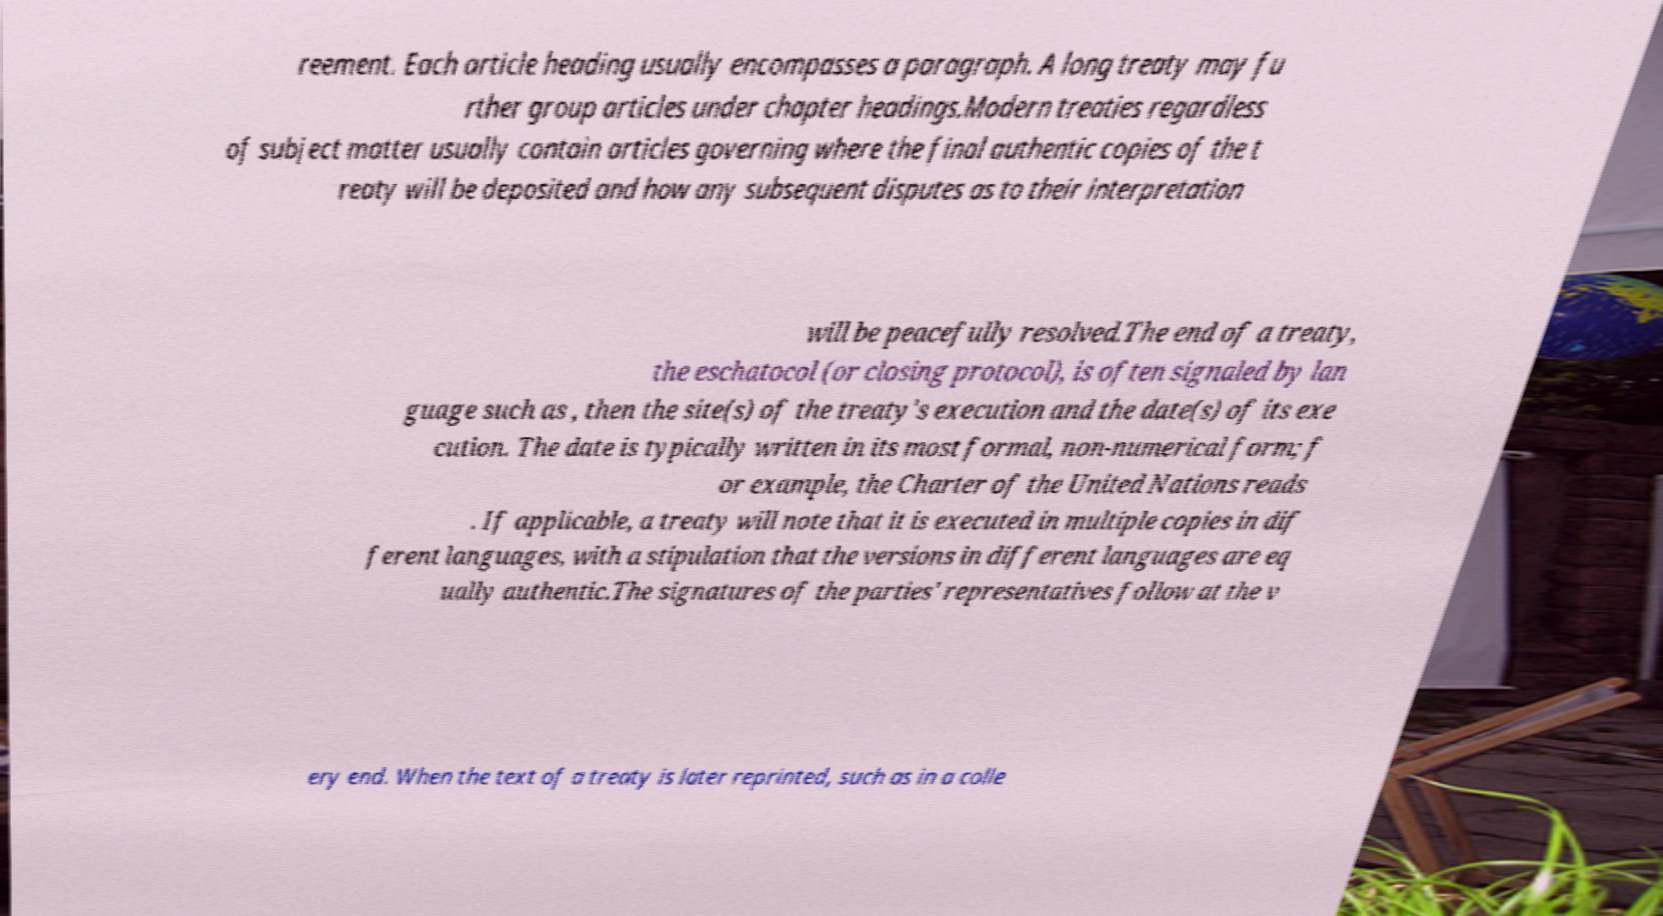Could you extract and type out the text from this image? reement. Each article heading usually encompasses a paragraph. A long treaty may fu rther group articles under chapter headings.Modern treaties regardless of subject matter usually contain articles governing where the final authentic copies of the t reaty will be deposited and how any subsequent disputes as to their interpretation will be peacefully resolved.The end of a treaty, the eschatocol (or closing protocol), is often signaled by lan guage such as , then the site(s) of the treaty's execution and the date(s) of its exe cution. The date is typically written in its most formal, non-numerical form; f or example, the Charter of the United Nations reads . If applicable, a treaty will note that it is executed in multiple copies in dif ferent languages, with a stipulation that the versions in different languages are eq ually authentic.The signatures of the parties' representatives follow at the v ery end. When the text of a treaty is later reprinted, such as in a colle 